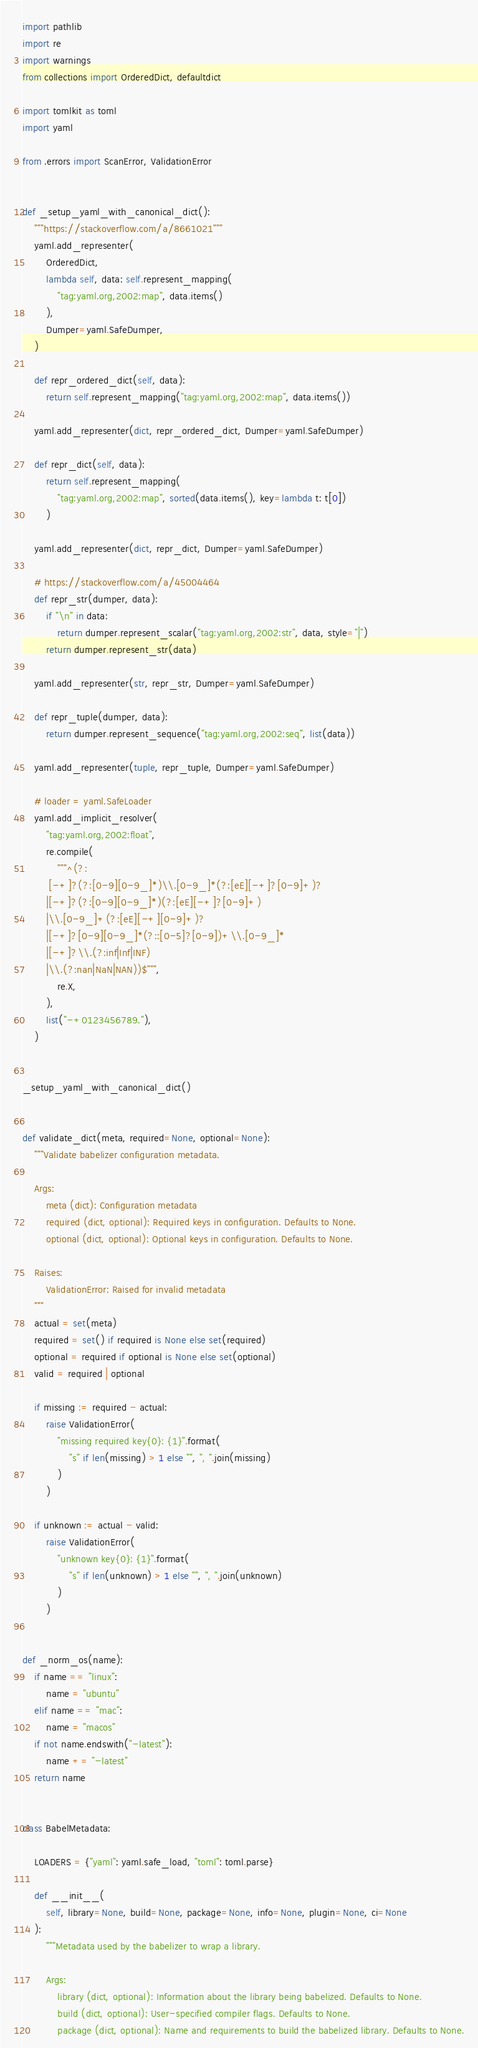<code> <loc_0><loc_0><loc_500><loc_500><_Python_>import pathlib
import re
import warnings
from collections import OrderedDict, defaultdict

import tomlkit as toml
import yaml

from .errors import ScanError, ValidationError


def _setup_yaml_with_canonical_dict():
    """https://stackoverflow.com/a/8661021"""
    yaml.add_representer(
        OrderedDict,
        lambda self, data: self.represent_mapping(
            "tag:yaml.org,2002:map", data.items()
        ),
        Dumper=yaml.SafeDumper,
    )

    def repr_ordered_dict(self, data):
        return self.represent_mapping("tag:yaml.org,2002:map", data.items())

    yaml.add_representer(dict, repr_ordered_dict, Dumper=yaml.SafeDumper)

    def repr_dict(self, data):
        return self.represent_mapping(
            "tag:yaml.org,2002:map", sorted(data.items(), key=lambda t: t[0])
        )

    yaml.add_representer(dict, repr_dict, Dumper=yaml.SafeDumper)

    # https://stackoverflow.com/a/45004464
    def repr_str(dumper, data):
        if "\n" in data:
            return dumper.represent_scalar("tag:yaml.org,2002:str", data, style="|")
        return dumper.represent_str(data)

    yaml.add_representer(str, repr_str, Dumper=yaml.SafeDumper)

    def repr_tuple(dumper, data):
        return dumper.represent_sequence("tag:yaml.org,2002:seq", list(data))

    yaml.add_representer(tuple, repr_tuple, Dumper=yaml.SafeDumper)

    # loader = yaml.SafeLoader
    yaml.add_implicit_resolver(
        "tag:yaml.org,2002:float",
        re.compile(
            """^(?:
         [-+]?(?:[0-9][0-9_]*)\\.[0-9_]*(?:[eE][-+]?[0-9]+)?
        |[-+]?(?:[0-9][0-9_]*)(?:[eE][-+]?[0-9]+)
        |\\.[0-9_]+(?:[eE][-+][0-9]+)?
        |[-+]?[0-9][0-9_]*(?::[0-5]?[0-9])+\\.[0-9_]*
        |[-+]?\\.(?:inf|Inf|INF)
        |\\.(?:nan|NaN|NAN))$""",
            re.X,
        ),
        list("-+0123456789."),
    )


_setup_yaml_with_canonical_dict()


def validate_dict(meta, required=None, optional=None):
    """Validate babelizer configuration metadata.

    Args:
        meta (dict): Configuration metadata
        required (dict, optional): Required keys in configuration. Defaults to None.
        optional (dict, optional): Optional keys in configuration. Defaults to None.

    Raises:
        ValidationError: Raised for invalid metadata
    """
    actual = set(meta)
    required = set() if required is None else set(required)
    optional = required if optional is None else set(optional)
    valid = required | optional

    if missing := required - actual:
        raise ValidationError(
            "missing required key{0}: {1}".format(
                "s" if len(missing) > 1 else "", ", ".join(missing)
            )
        )

    if unknown := actual - valid:
        raise ValidationError(
            "unknown key{0}: {1}".format(
                "s" if len(unknown) > 1 else "", ", ".join(unknown)
            )
        )


def _norm_os(name):
    if name == "linux":
        name = "ubuntu"
    elif name == "mac":
        name = "macos"
    if not name.endswith("-latest"):
        name += "-latest"
    return name


class BabelMetadata:

    LOADERS = {"yaml": yaml.safe_load, "toml": toml.parse}

    def __init__(
        self, library=None, build=None, package=None, info=None, plugin=None, ci=None
    ):
        """Metadata used by the babelizer to wrap a library.

        Args:
            library (dict, optional): Information about the library being babelized. Defaults to None.
            build (dict, optional): User-specified compiler flags. Defaults to None.
            package (dict, optional): Name and requirements to build the babelized library. Defaults to None.</code> 